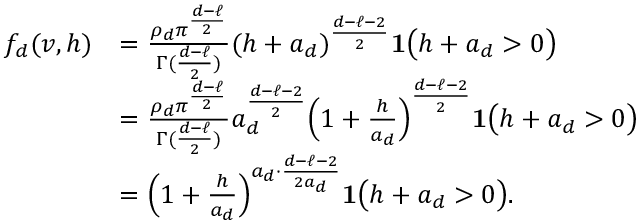<formula> <loc_0><loc_0><loc_500><loc_500>\begin{array} { r l } { f _ { d } ( v , h ) } & { = { \frac { \rho _ { d } \pi ^ { \frac { d - \ell } { 2 } } } { \Gamma ( { \frac { d - \ell } { 2 } } ) } } ( h + a _ { d } ) ^ { { \frac { d - \ell - 2 } { 2 } } } { 1 } \left ( h + a _ { d } > 0 \right ) } \\ & { = { \frac { \rho _ { d } \pi ^ { \frac { d - \ell } { 2 } } } { \Gamma ( { \frac { d - \ell } { 2 } } ) } } a _ { d } ^ { \frac { d - \ell - 2 } { 2 } } \left ( 1 + { \frac { h } { a _ { d } } } \right ) ^ { { \frac { d - \ell - 2 } { 2 } } } { 1 } \left ( h + a _ { d } > 0 \right ) } \\ & { = \left ( 1 + { \frac { h } { a _ { d } } } \right ) ^ { a _ { d } \cdot { \frac { d - \ell - 2 } { 2 a _ { d } } } } { 1 } \left ( h + a _ { d } > 0 \right ) . } \end{array}</formula> 